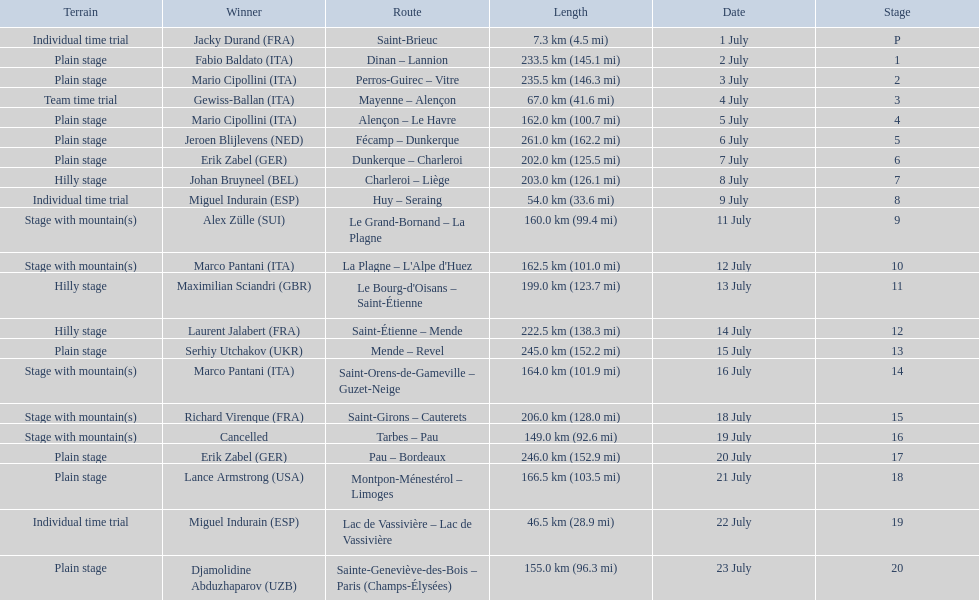What were the dates of the 1995 tour de france? 1 July, 2 July, 3 July, 4 July, 5 July, 6 July, 7 July, 8 July, 9 July, 11 July, 12 July, 13 July, 14 July, 15 July, 16 July, 18 July, 19 July, 20 July, 21 July, 22 July, 23 July. What was the length for july 8th? 203.0 km (126.1 mi). 